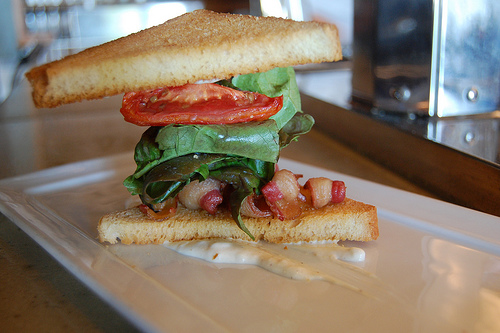<image>
Is there a sauce under the sandwich? Yes. The sauce is positioned underneath the sandwich, with the sandwich above it in the vertical space. 